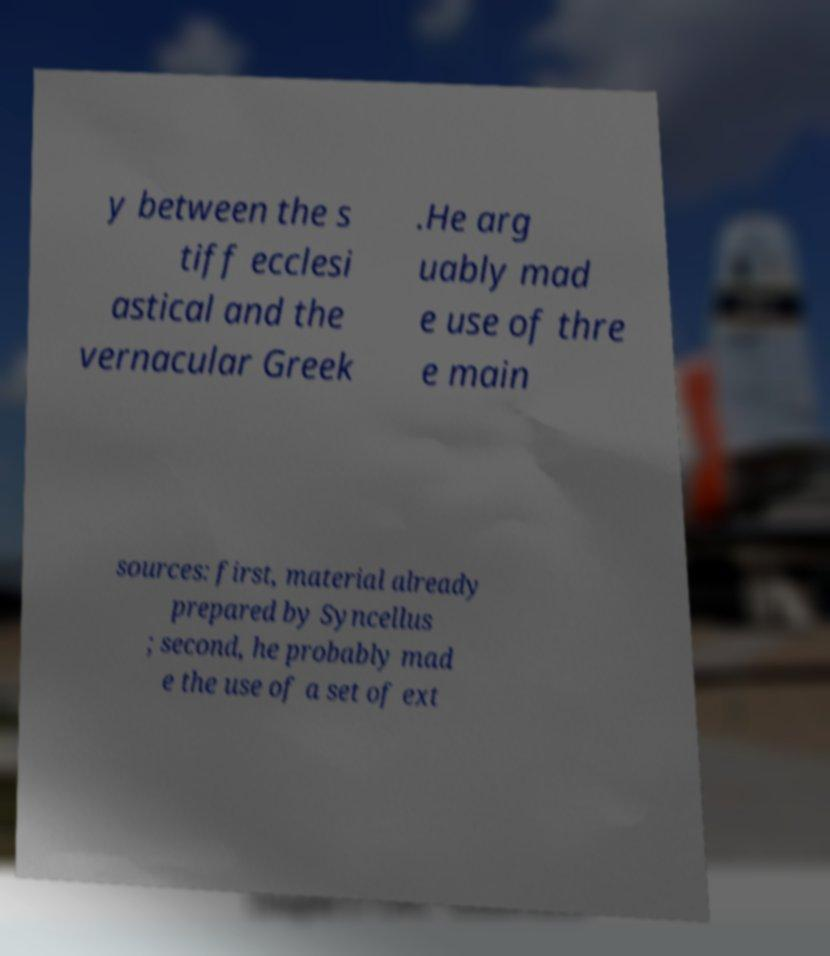Can you accurately transcribe the text from the provided image for me? y between the s tiff ecclesi astical and the vernacular Greek .He arg uably mad e use of thre e main sources: first, material already prepared by Syncellus ; second, he probably mad e the use of a set of ext 